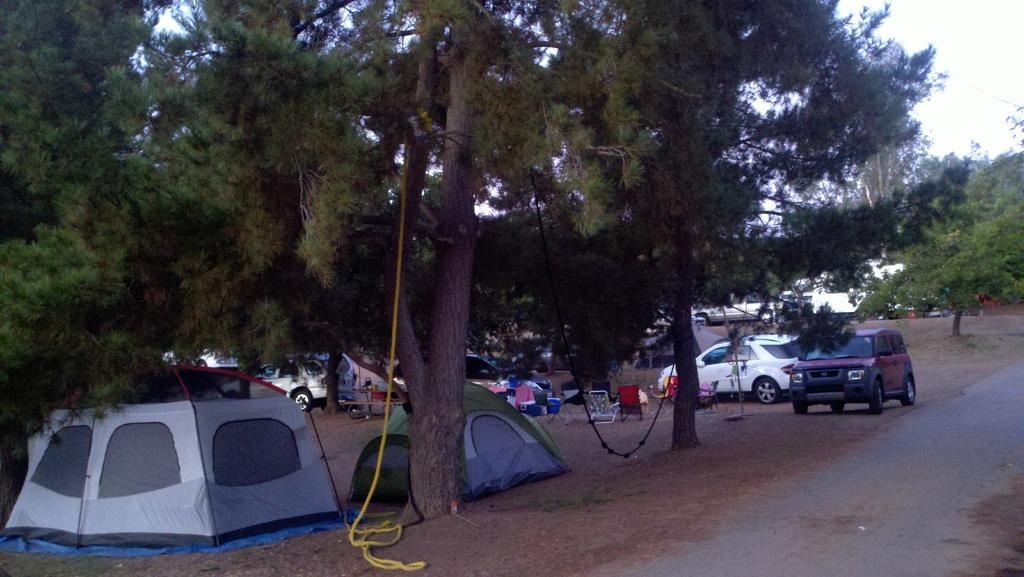How would you summarize this image in a sentence or two? In the foreground of the image we can see some stents placed on the ground, some ropes tied to trees. In the center of the image we can see group of vehicles parked on the ground, a group of chairs, containers and table placed on the ground. In the background, we can see a group of trees, pathways and the sky. 